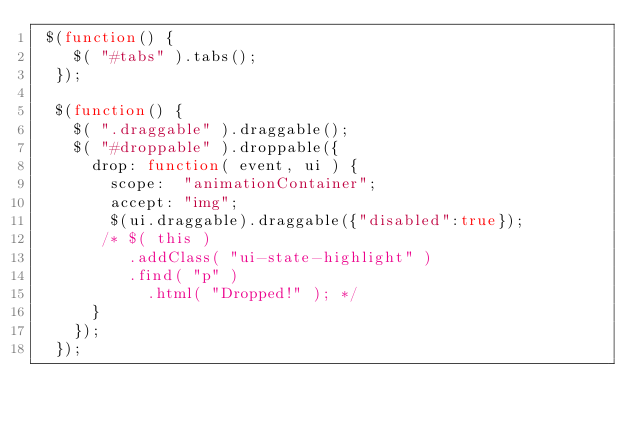Convert code to text. <code><loc_0><loc_0><loc_500><loc_500><_JavaScript_> $(function() {
    $( "#tabs" ).tabs();
  });

  $(function() {
    $( ".draggable" ).draggable();
    $( "#droppable" ).droppable({
      drop: function( event, ui ) {
        scope:  "animationContainer";
        accept: "img";
        $(ui.draggable).draggable({"disabled":true});
       /* $( this )
          .addClass( "ui-state-highlight" )
          .find( "p" )
            .html( "Dropped!" ); */
      }
    });
  });</code> 